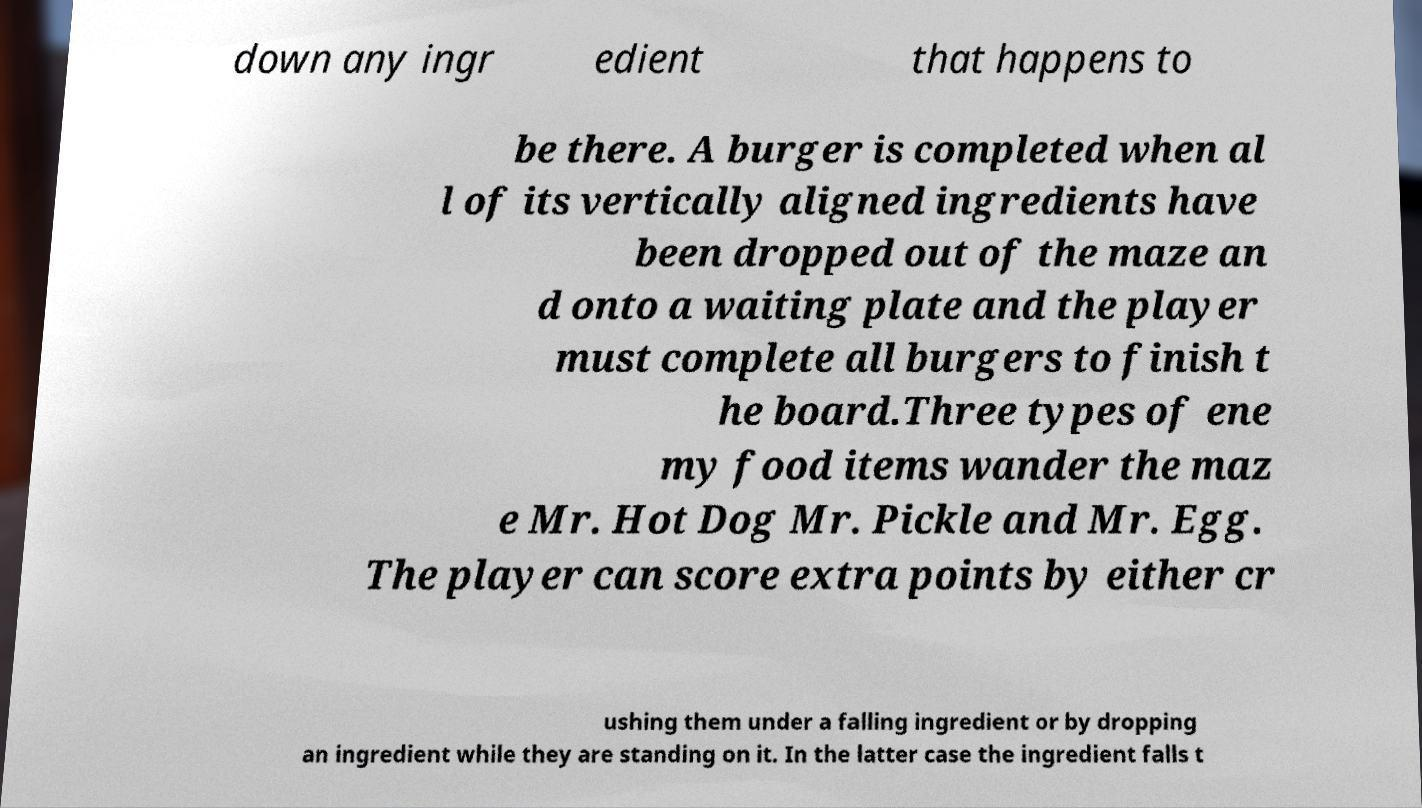For documentation purposes, I need the text within this image transcribed. Could you provide that? down any ingr edient that happens to be there. A burger is completed when al l of its vertically aligned ingredients have been dropped out of the maze an d onto a waiting plate and the player must complete all burgers to finish t he board.Three types of ene my food items wander the maz e Mr. Hot Dog Mr. Pickle and Mr. Egg. The player can score extra points by either cr ushing them under a falling ingredient or by dropping an ingredient while they are standing on it. In the latter case the ingredient falls t 